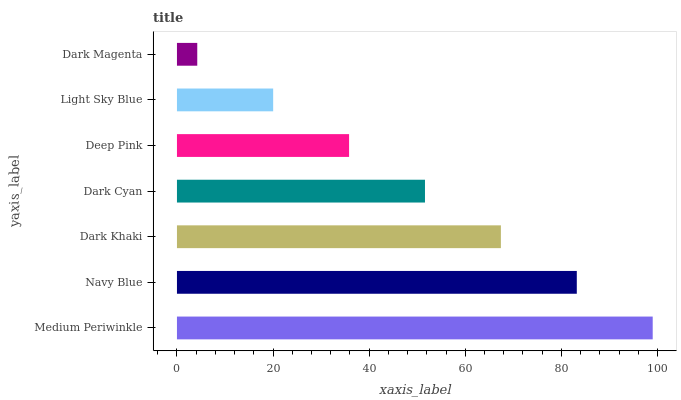Is Dark Magenta the minimum?
Answer yes or no. Yes. Is Medium Periwinkle the maximum?
Answer yes or no. Yes. Is Navy Blue the minimum?
Answer yes or no. No. Is Navy Blue the maximum?
Answer yes or no. No. Is Medium Periwinkle greater than Navy Blue?
Answer yes or no. Yes. Is Navy Blue less than Medium Periwinkle?
Answer yes or no. Yes. Is Navy Blue greater than Medium Periwinkle?
Answer yes or no. No. Is Medium Periwinkle less than Navy Blue?
Answer yes or no. No. Is Dark Cyan the high median?
Answer yes or no. Yes. Is Dark Cyan the low median?
Answer yes or no. Yes. Is Light Sky Blue the high median?
Answer yes or no. No. Is Medium Periwinkle the low median?
Answer yes or no. No. 